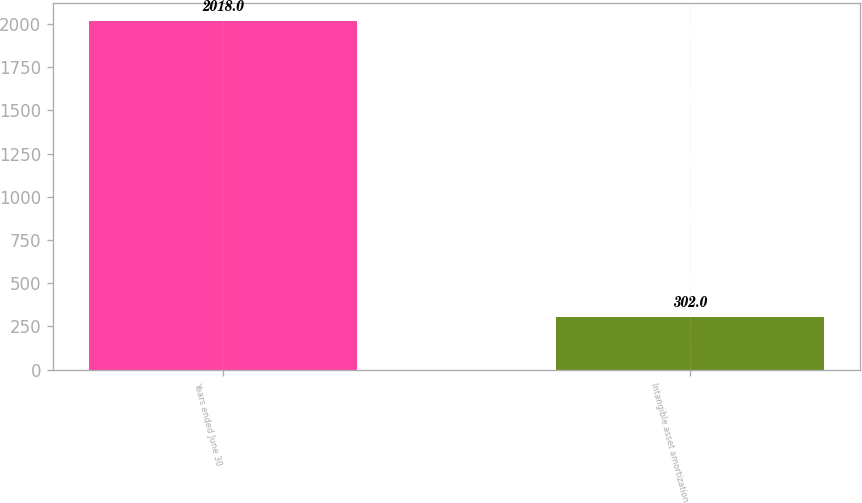Convert chart. <chart><loc_0><loc_0><loc_500><loc_500><bar_chart><fcel>Years ended June 30<fcel>Intangible asset amortization<nl><fcel>2018<fcel>302<nl></chart> 